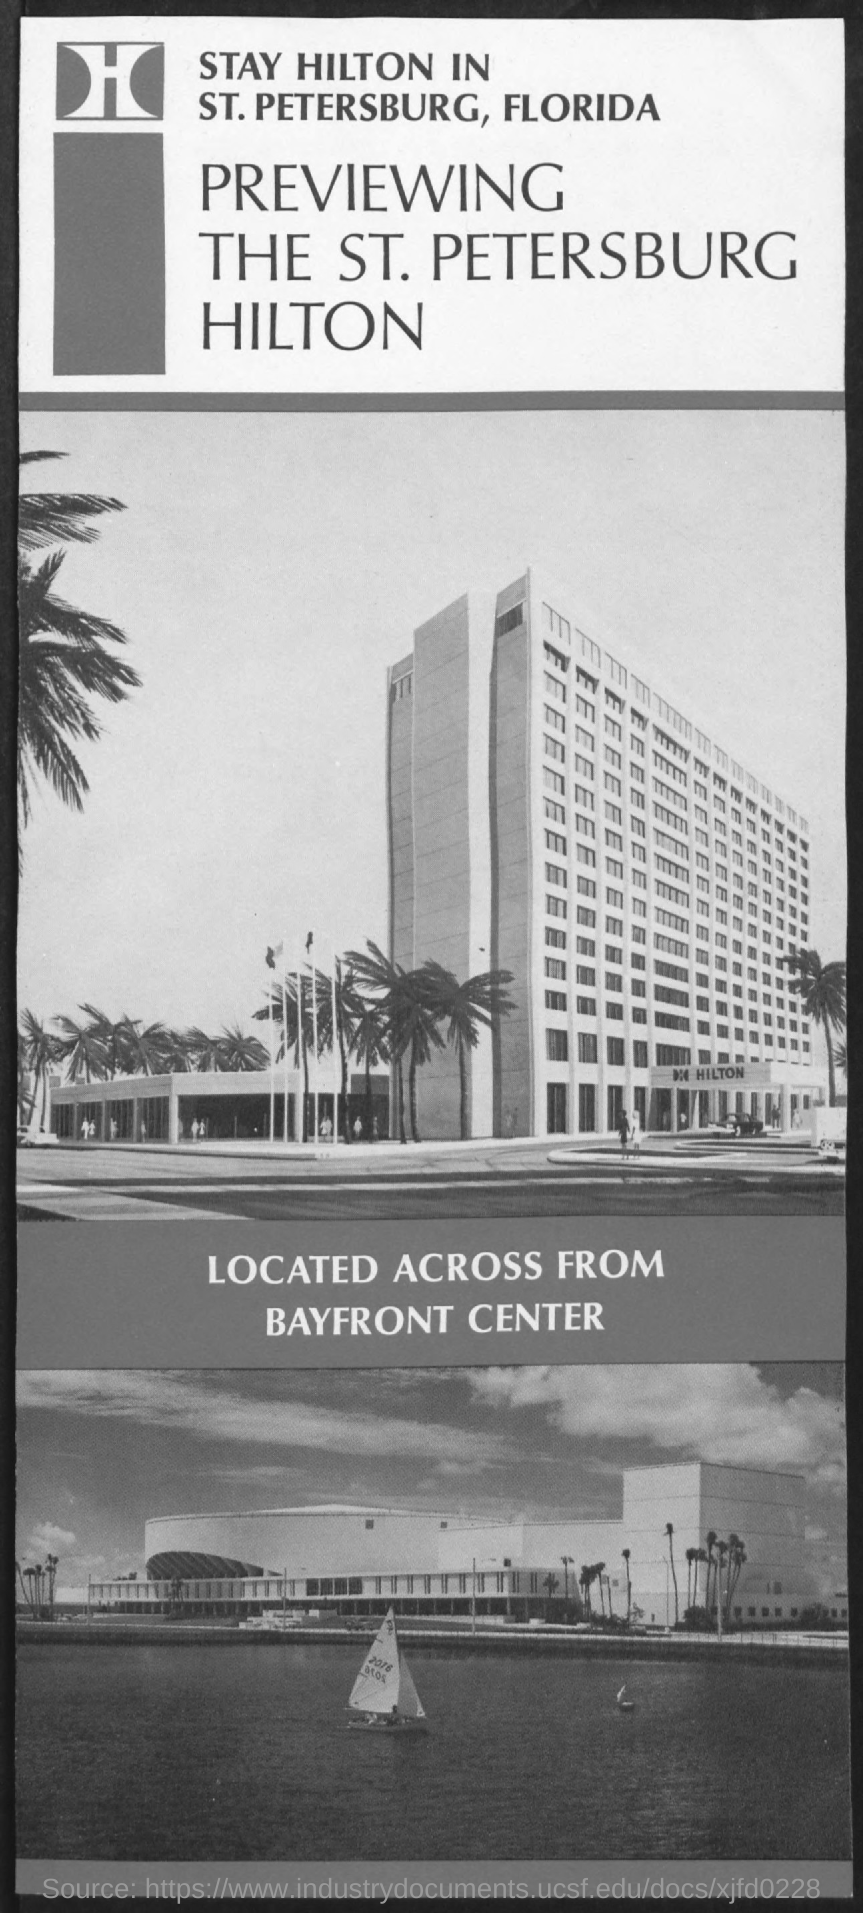What is the third title in the document?
Give a very brief answer. Located across from bayfront center. 